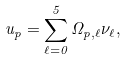<formula> <loc_0><loc_0><loc_500><loc_500>u _ { p } = \sum _ { \ell = 0 } ^ { 5 } \Omega _ { p , \ell } \nu _ { \ell } ,</formula> 